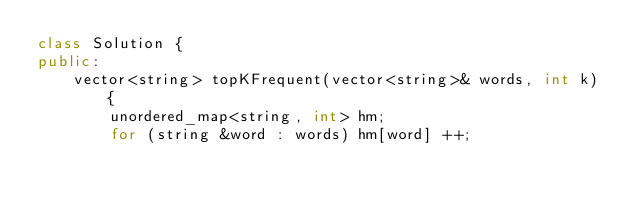Convert code to text. <code><loc_0><loc_0><loc_500><loc_500><_C++_>class Solution {
public:
    vector<string> topKFrequent(vector<string>& words, int k) {
        unordered_map<string, int> hm;
        for (string &word : words) hm[word] ++;</code> 